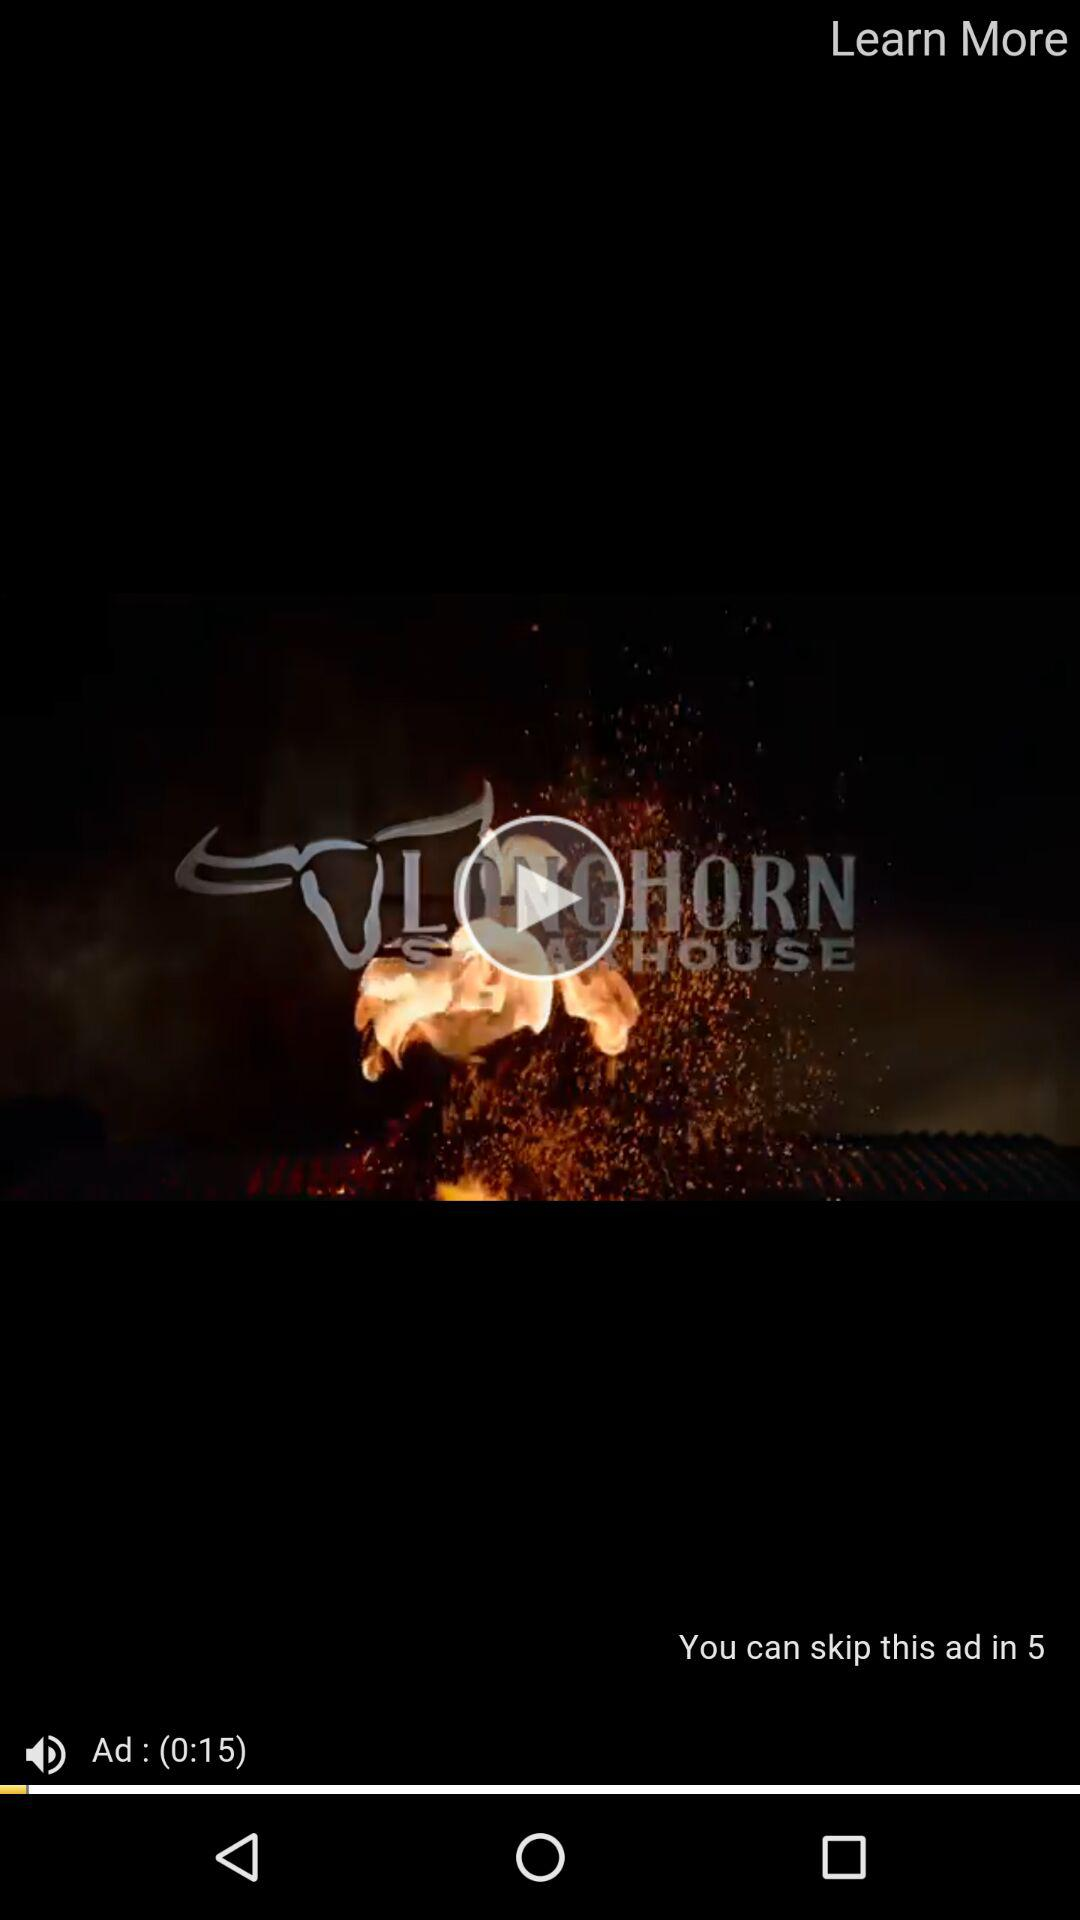How long is the video?
Answer the question using a single word or phrase. 0:15 